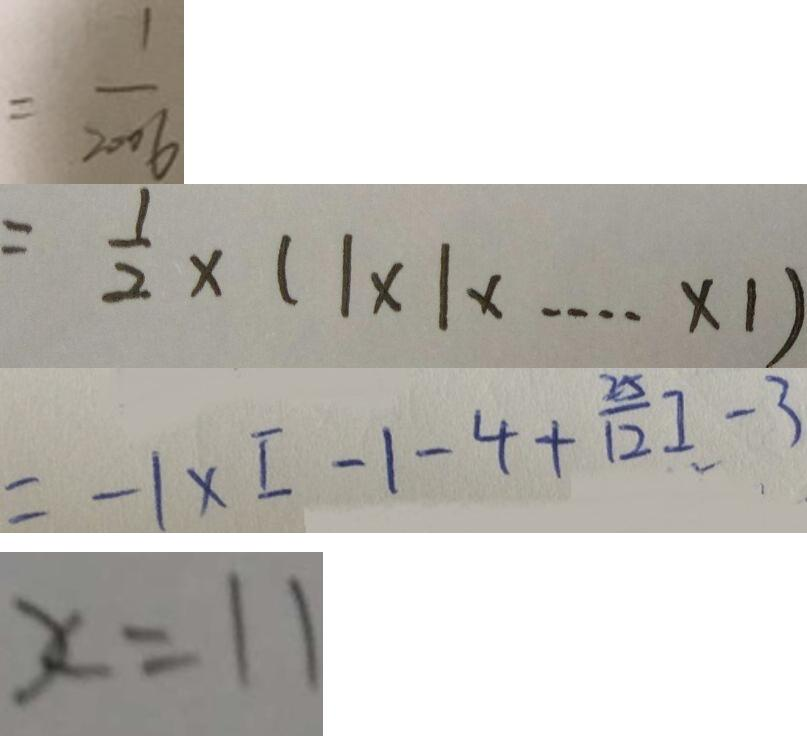<formula> <loc_0><loc_0><loc_500><loc_500>= \frac { 1 } { 2 0 0 6 } 
 = \frac { 1 } { 2 } \times ( 1 \times 1 \times \cdots \times 1 ) 
 = - 1 \times [ - 1 - 4 + \frac { 2 5 } { 1 2 } ] - 3 
 x = 1 1</formula> 